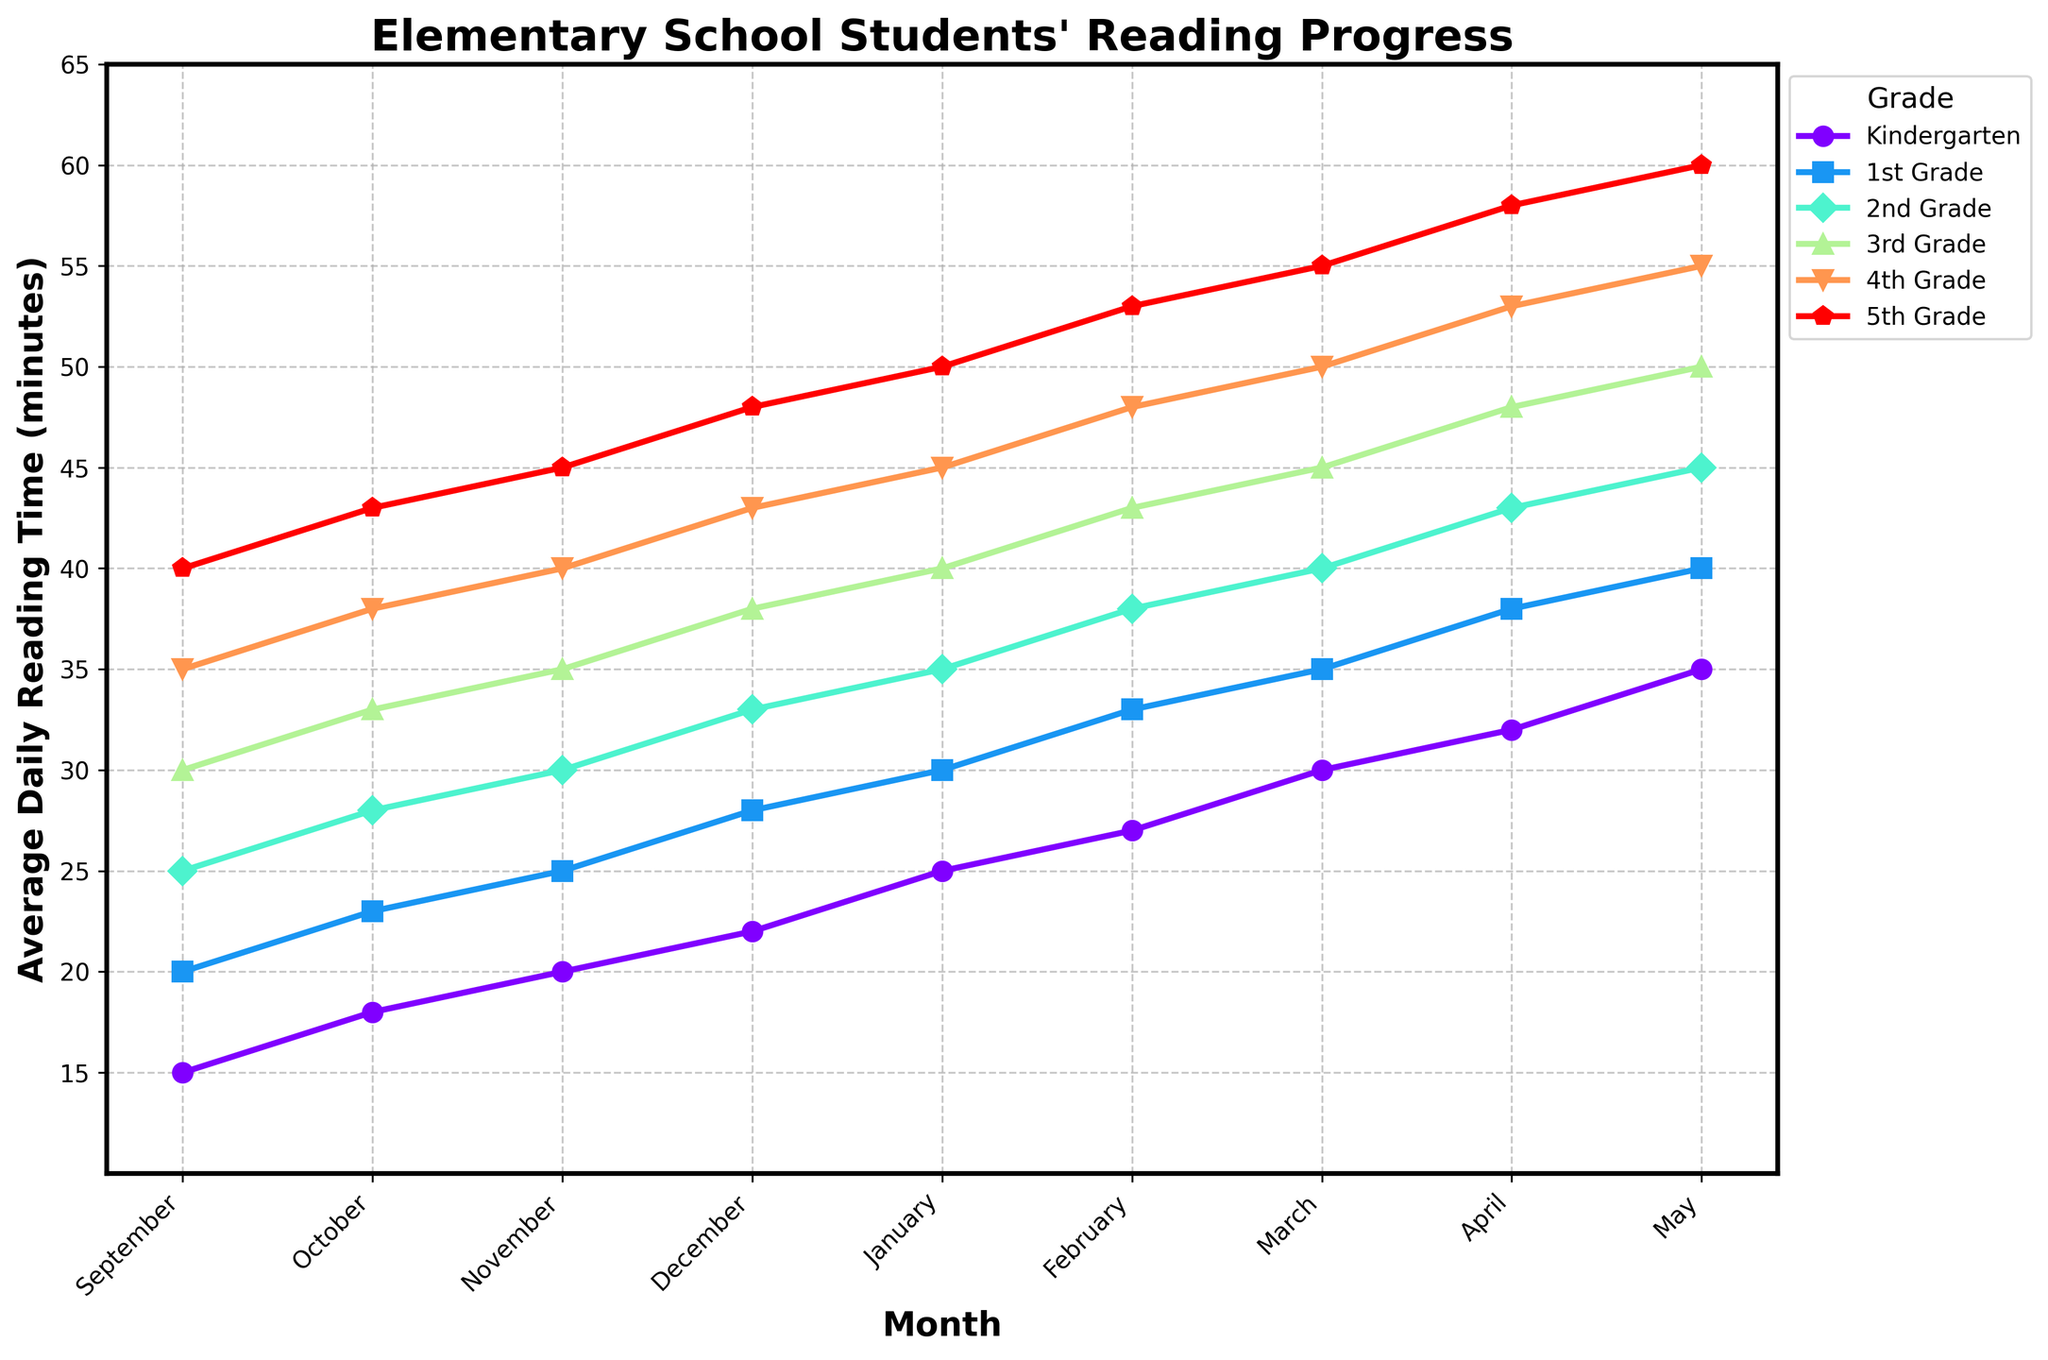What is the difference in average daily reading time between Kindergarten and 5th Grade in May? In May, Kindergarten has 35 minutes and 5th Grade has 60 minutes. The difference is 60 - 35.
Answer: 25 Which month shows the highest increase in average daily reading time for 3rd Grade? Examine the reading times for 3rd Grade month by month. The highest increase is from March (45 minutes) to April (48 minutes), an increase of 3 minutes.
Answer: April Which grade shows the least average daily reading time in September? Look at the September data for all grades. Kindergarten has the lowest at 15 minutes.
Answer: Kindergarten By how many minutes does the 2nd Grade improve their reading time from January to February? In January, the 2nd Grade has 35 minutes and in February, it has 38 minutes. The improvement is 38 - 35.
Answer: 3 What is the total reading time for 1st Grade over the entire school year? Sum up the reading times for 1st Grade from September to May: 20 + 23 + 25 + 28 + 30 + 33 + 35 + 38 + 40 = 272 minutes.
Answer: 272 Which two grades have the same average daily reading time in December? In December, both 1st Grade and 2nd Grade have 28 and 33 minutes respectively with different values, No two grades have the same average reading time.
Answer: None In which month do all grades show the highest reading increase compared to the previous month? By looking across months, identify the month where the increases seem most consistent and prominent. For most grades, the highest increases occur from February to March.
Answer: March How does the reading time trend for Kindergarten compare to that of the 5th Grade over the school year? Both Kindergarten and 5th Grade show an upward trend, but the increase for 5th Grade is steeper. Kindergarten starts at a lower baseline and increases steadily, while 5th Grade starts higher and shows a more significant overall growth.
Answer: Both increase What is the average reading time for 4th Grade in the first semester (September to December)? Sum up the reading times from September to December for 4th Grade: 35 + 38 + 40 + 43 = 156. Divide by 4 (number of months): 156 / 4.
Answer: 39 